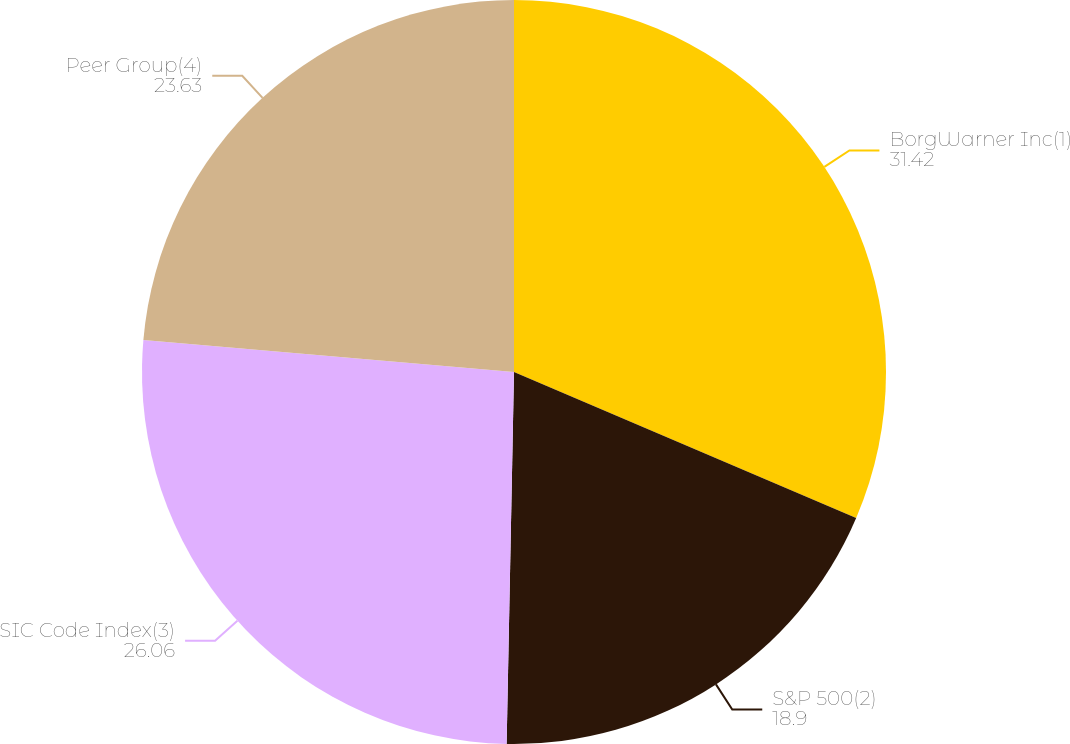<chart> <loc_0><loc_0><loc_500><loc_500><pie_chart><fcel>BorgWarner Inc(1)<fcel>S&P 500(2)<fcel>SIC Code Index(3)<fcel>Peer Group(4)<nl><fcel>31.42%<fcel>18.9%<fcel>26.06%<fcel>23.63%<nl></chart> 